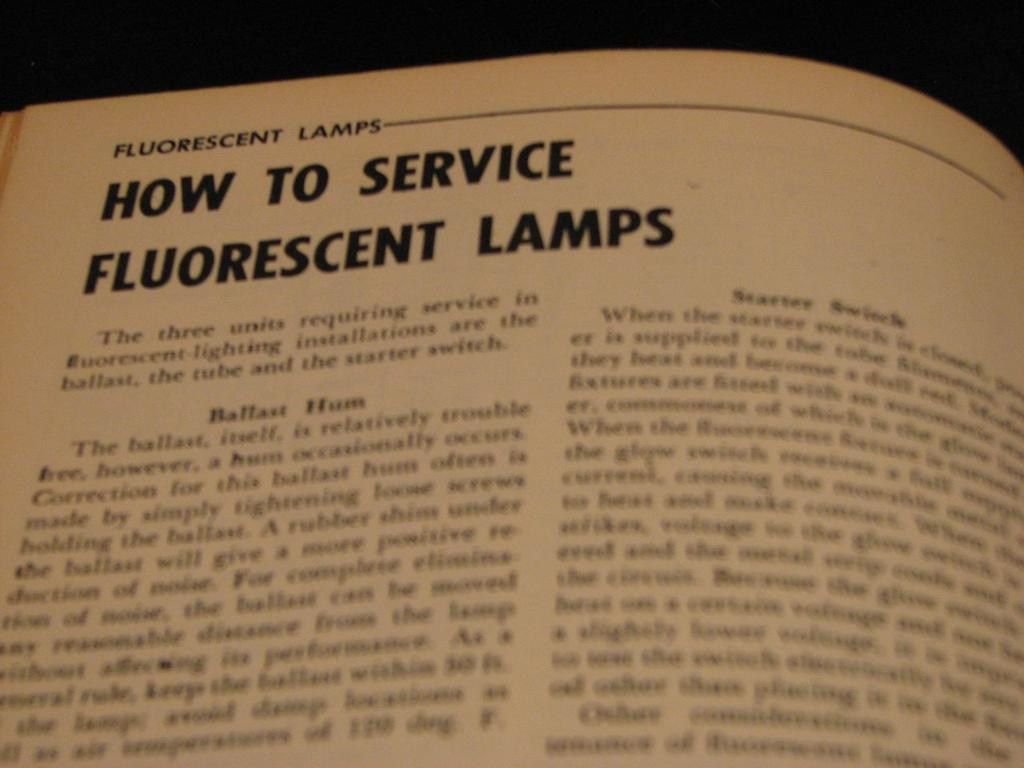Provide a one-sentence caption for the provided image. An article about how to service fluorescent lamps begins with the words "The three units". 